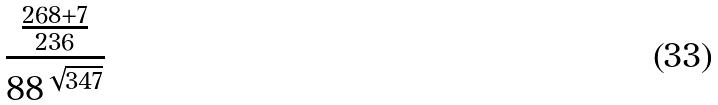<formula> <loc_0><loc_0><loc_500><loc_500>\frac { \frac { 2 6 8 + 7 } { 2 3 6 } } { 8 8 ^ { \sqrt { 3 4 7 } } }</formula> 